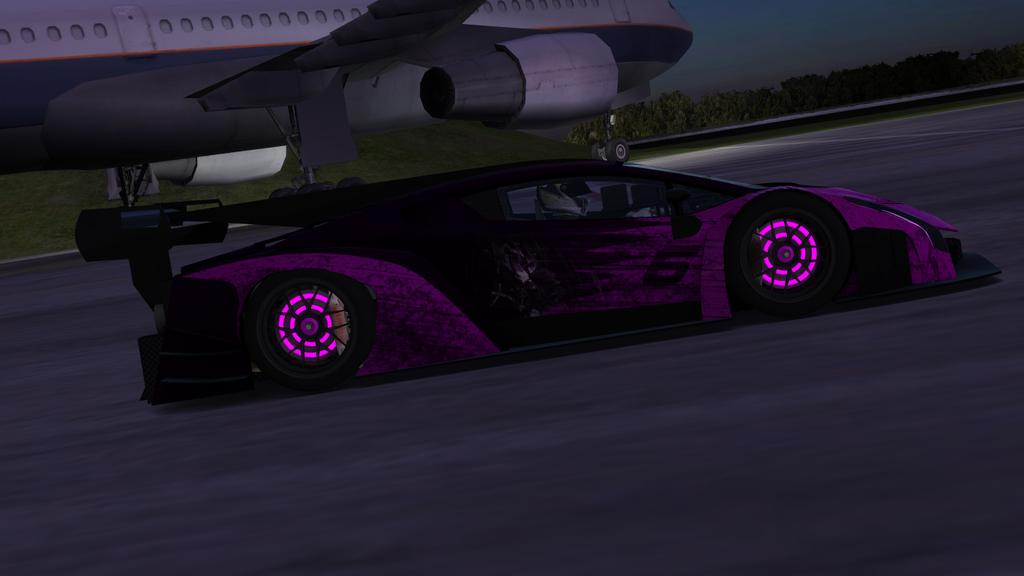What color is the car in the image? The car in the image is purple. What is located behind the car in the image? There is an airplane behind the car in the image. What can be seen in the background of the image? There are trees in the background of the image. What causes the car to burst into flames in the image? There is no indication in the image that the car is on fire or bursting into flames. 